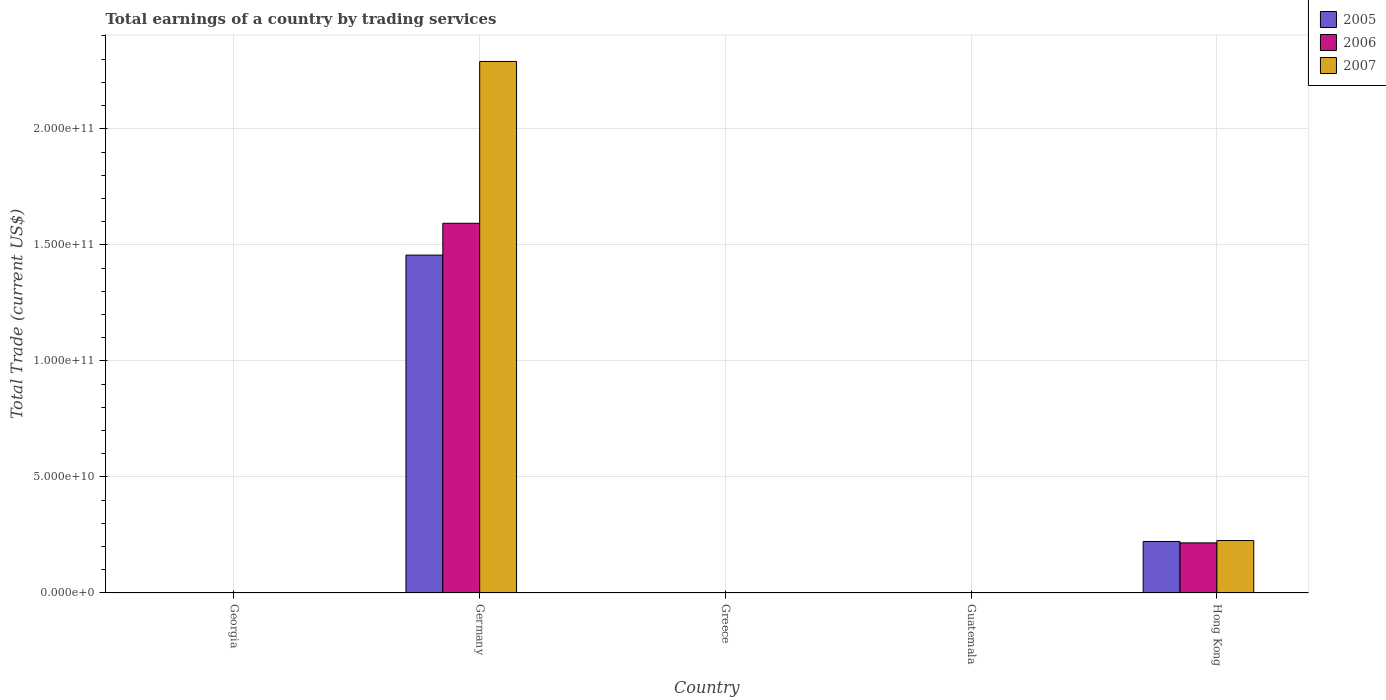Are the number of bars on each tick of the X-axis equal?
Provide a succinct answer. No. How many bars are there on the 1st tick from the right?
Offer a terse response. 3. What is the label of the 4th group of bars from the left?
Make the answer very short. Guatemala. Across all countries, what is the maximum total earnings in 2005?
Keep it short and to the point. 1.46e+11. In which country was the total earnings in 2007 maximum?
Keep it short and to the point. Germany. What is the total total earnings in 2006 in the graph?
Your response must be concise. 1.81e+11. What is the difference between the total earnings in 2006 in Germany and that in Hong Kong?
Offer a very short reply. 1.38e+11. What is the difference between the total earnings in 2007 in Greece and the total earnings in 2006 in Germany?
Keep it short and to the point. -1.59e+11. What is the average total earnings in 2007 per country?
Keep it short and to the point. 5.03e+1. What is the difference between the total earnings of/in 2007 and total earnings of/in 2005 in Hong Kong?
Offer a terse response. 4.01e+08. What is the ratio of the total earnings in 2006 in Germany to that in Hong Kong?
Give a very brief answer. 7.38. What is the difference between the highest and the lowest total earnings in 2005?
Keep it short and to the point. 1.46e+11. Is it the case that in every country, the sum of the total earnings in 2006 and total earnings in 2007 is greater than the total earnings in 2005?
Keep it short and to the point. No. How many bars are there?
Ensure brevity in your answer.  6. Are all the bars in the graph horizontal?
Offer a terse response. No. How many countries are there in the graph?
Keep it short and to the point. 5. Are the values on the major ticks of Y-axis written in scientific E-notation?
Make the answer very short. Yes. Does the graph contain any zero values?
Your response must be concise. Yes. Does the graph contain grids?
Make the answer very short. Yes. How many legend labels are there?
Make the answer very short. 3. What is the title of the graph?
Offer a very short reply. Total earnings of a country by trading services. Does "1965" appear as one of the legend labels in the graph?
Your answer should be very brief. No. What is the label or title of the X-axis?
Your answer should be very brief. Country. What is the label or title of the Y-axis?
Your answer should be very brief. Total Trade (current US$). What is the Total Trade (current US$) in 2005 in Georgia?
Make the answer very short. 0. What is the Total Trade (current US$) in 2006 in Georgia?
Offer a terse response. 0. What is the Total Trade (current US$) in 2007 in Georgia?
Ensure brevity in your answer.  0. What is the Total Trade (current US$) of 2005 in Germany?
Keep it short and to the point. 1.46e+11. What is the Total Trade (current US$) in 2006 in Germany?
Ensure brevity in your answer.  1.59e+11. What is the Total Trade (current US$) in 2007 in Germany?
Offer a terse response. 2.29e+11. What is the Total Trade (current US$) of 2005 in Greece?
Make the answer very short. 0. What is the Total Trade (current US$) of 2007 in Greece?
Your response must be concise. 0. What is the Total Trade (current US$) of 2005 in Guatemala?
Offer a very short reply. 0. What is the Total Trade (current US$) of 2005 in Hong Kong?
Provide a short and direct response. 2.22e+1. What is the Total Trade (current US$) in 2006 in Hong Kong?
Your answer should be compact. 2.16e+1. What is the Total Trade (current US$) of 2007 in Hong Kong?
Offer a terse response. 2.26e+1. Across all countries, what is the maximum Total Trade (current US$) of 2005?
Your answer should be very brief. 1.46e+11. Across all countries, what is the maximum Total Trade (current US$) in 2006?
Keep it short and to the point. 1.59e+11. Across all countries, what is the maximum Total Trade (current US$) of 2007?
Ensure brevity in your answer.  2.29e+11. Across all countries, what is the minimum Total Trade (current US$) in 2005?
Ensure brevity in your answer.  0. Across all countries, what is the minimum Total Trade (current US$) of 2006?
Provide a short and direct response. 0. Across all countries, what is the minimum Total Trade (current US$) in 2007?
Give a very brief answer. 0. What is the total Total Trade (current US$) in 2005 in the graph?
Offer a terse response. 1.68e+11. What is the total Total Trade (current US$) in 2006 in the graph?
Offer a terse response. 1.81e+11. What is the total Total Trade (current US$) of 2007 in the graph?
Give a very brief answer. 2.52e+11. What is the difference between the Total Trade (current US$) of 2005 in Germany and that in Hong Kong?
Keep it short and to the point. 1.23e+11. What is the difference between the Total Trade (current US$) of 2006 in Germany and that in Hong Kong?
Your answer should be very brief. 1.38e+11. What is the difference between the Total Trade (current US$) of 2007 in Germany and that in Hong Kong?
Your answer should be compact. 2.06e+11. What is the difference between the Total Trade (current US$) of 2005 in Germany and the Total Trade (current US$) of 2006 in Hong Kong?
Your response must be concise. 1.24e+11. What is the difference between the Total Trade (current US$) in 2005 in Germany and the Total Trade (current US$) in 2007 in Hong Kong?
Offer a very short reply. 1.23e+11. What is the difference between the Total Trade (current US$) in 2006 in Germany and the Total Trade (current US$) in 2007 in Hong Kong?
Give a very brief answer. 1.37e+11. What is the average Total Trade (current US$) in 2005 per country?
Provide a short and direct response. 3.36e+1. What is the average Total Trade (current US$) of 2006 per country?
Your answer should be very brief. 3.62e+1. What is the average Total Trade (current US$) of 2007 per country?
Your answer should be compact. 5.03e+1. What is the difference between the Total Trade (current US$) in 2005 and Total Trade (current US$) in 2006 in Germany?
Your answer should be very brief. -1.37e+1. What is the difference between the Total Trade (current US$) in 2005 and Total Trade (current US$) in 2007 in Germany?
Make the answer very short. -8.34e+1. What is the difference between the Total Trade (current US$) of 2006 and Total Trade (current US$) of 2007 in Germany?
Your response must be concise. -6.97e+1. What is the difference between the Total Trade (current US$) in 2005 and Total Trade (current US$) in 2006 in Hong Kong?
Ensure brevity in your answer.  6.01e+08. What is the difference between the Total Trade (current US$) of 2005 and Total Trade (current US$) of 2007 in Hong Kong?
Your answer should be very brief. -4.01e+08. What is the difference between the Total Trade (current US$) of 2006 and Total Trade (current US$) of 2007 in Hong Kong?
Make the answer very short. -1.00e+09. What is the ratio of the Total Trade (current US$) of 2005 in Germany to that in Hong Kong?
Give a very brief answer. 6.56. What is the ratio of the Total Trade (current US$) of 2006 in Germany to that in Hong Kong?
Ensure brevity in your answer.  7.38. What is the ratio of the Total Trade (current US$) in 2007 in Germany to that in Hong Kong?
Make the answer very short. 10.14. What is the difference between the highest and the lowest Total Trade (current US$) in 2005?
Provide a short and direct response. 1.46e+11. What is the difference between the highest and the lowest Total Trade (current US$) of 2006?
Offer a terse response. 1.59e+11. What is the difference between the highest and the lowest Total Trade (current US$) in 2007?
Offer a very short reply. 2.29e+11. 